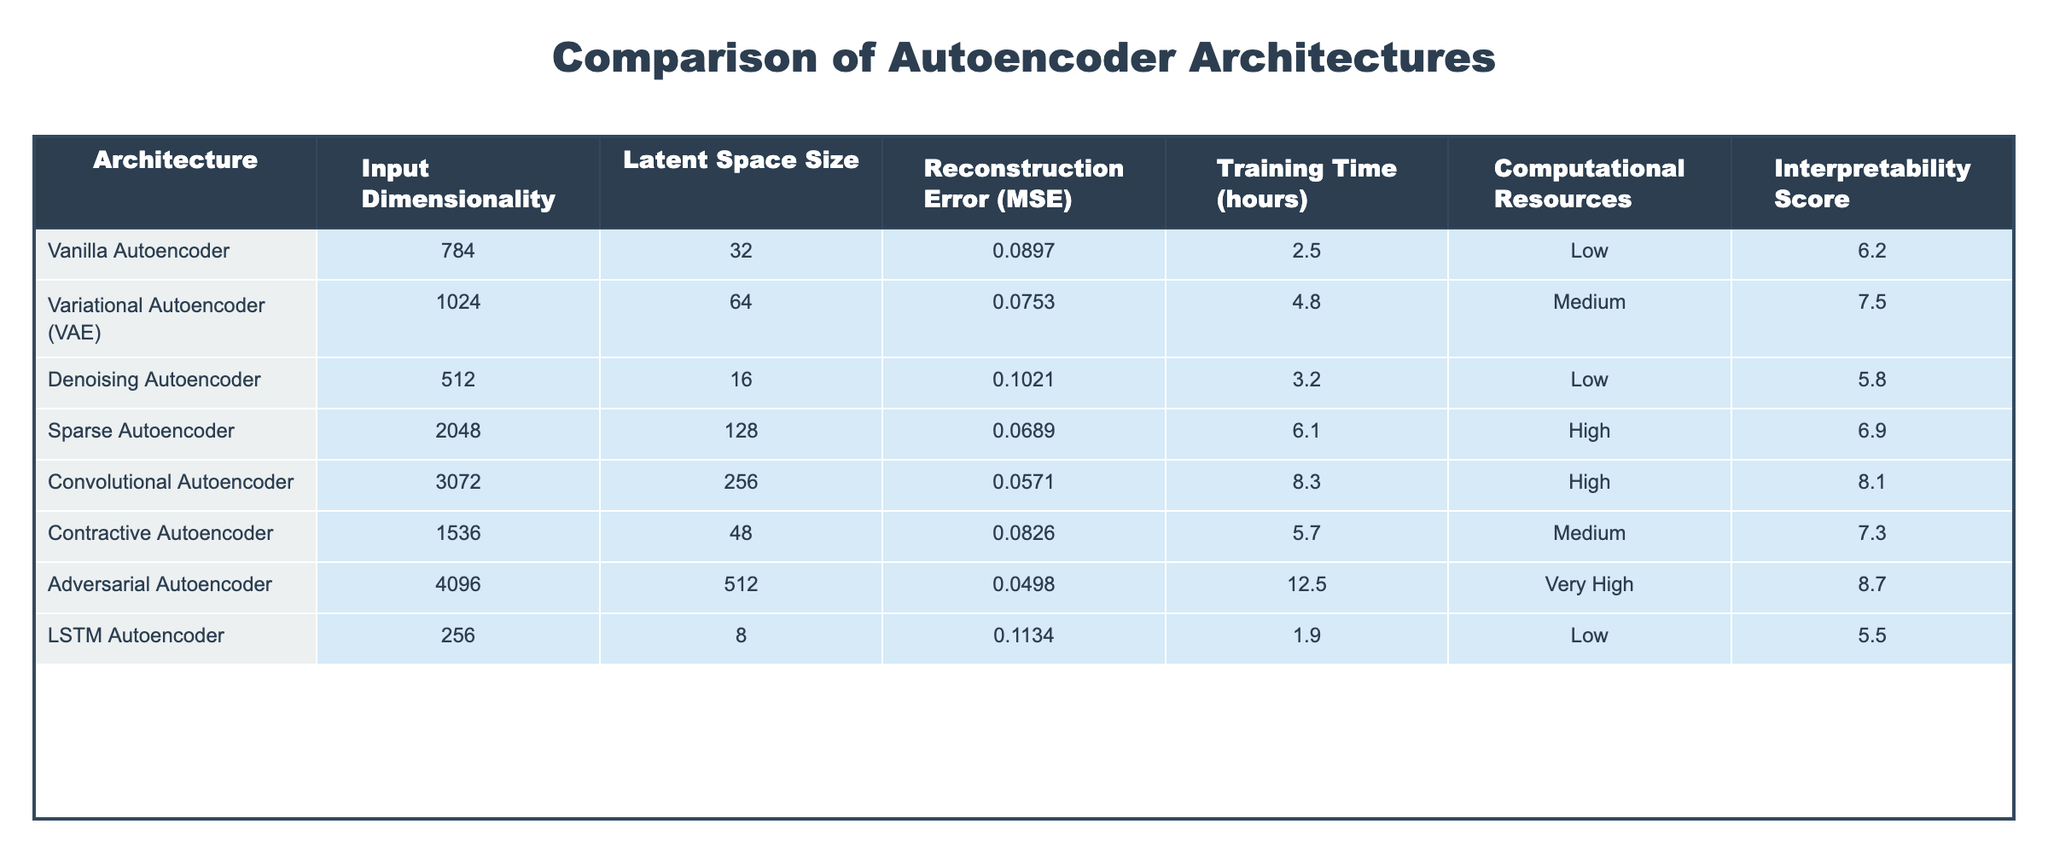What is the reconstruction error (MSE) for the Convolutional Autoencoder? The table lists the reconstruction error (MSE) for the Convolutional Autoencoder as 0.0571. This value can be directly found in the corresponding row.
Answer: 0.0571 Which autoencoder architecture has the largest latent space size? From the table, the Adversarial Autoencoder has the largest latent space size of 512, as this is the highest value listed under Latent Space Size.
Answer: 512 What is the average training time for the autoencoders in hours? To find the average, we sum the training times: 2.5 + 4.8 + 3.2 + 6.1 + 8.3 + 5.7 + 12.5 + 1.9 = 44.0. There are 8 architectures, so the average is 44.0 / 8 = 5.5 hours.
Answer: 5.5 Is the Denoising Autoencoder more interpretable than the LSTM Autoencoder? The interpretability score for the Denoising Autoencoder is 5.8, while for the LSTM Autoencoder it is 5.5. Since 5.8 is greater than 5.5, it is more interpretable.
Answer: Yes Which architecture has the lowest reconstruction error, and what is that value? Looking at the reconstruction errors in the table, the Adversarial Autoencoder has the lowest error of 0.0498 as it has the smallest value in the Reconstruction Error (MSE) column.
Answer: Adversarial Autoencoder, 0.0498 Between the Vanilla Autoencoder and the Sparse Autoencoder, which has a longer training time? The training time for the Vanilla Autoencoder is 2.5 hours, while for the Sparse Autoencoder it is 6.1 hours. Since 6.1 is greater than 2.5, the Sparse Autoencoder has a longer training time.
Answer: Sparse Autoencoder What is the difference in interpretability score between the Variational Autoencoder and the Denoising Autoencoder? The interpretability score of the Variational Autoencoder is 7.5 and that of the Denoising Autoencoder is 5.8. The difference is 7.5 - 5.8 = 1.7.
Answer: 1.7 Which two architectures have Medium as their computational resources? Scanning through the table shows that both the Variational Autoencoder and Contractive Autoencoder are categorized under Medium for computational resources.
Answer: Variational Autoencoder, Contractive Autoencoder What is the total reconstruction error for all the autoencoder architectures? Summing the reconstruction errors from the table gives: 0.0897 + 0.0753 + 0.1021 + 0.0689 + 0.0571 + 0.0826 + 0.0498 + 0.1134 = 0.6389.
Answer: 0.6389 Which architecture requires the least computational resources, and what is the score? Referring to the table, the architectures with the least computational resources listed as Low are the Vanilla Autoencoder, Denoising Autoencoder, and LSTM Autoencoder. The score is "Low."
Answer: Low 